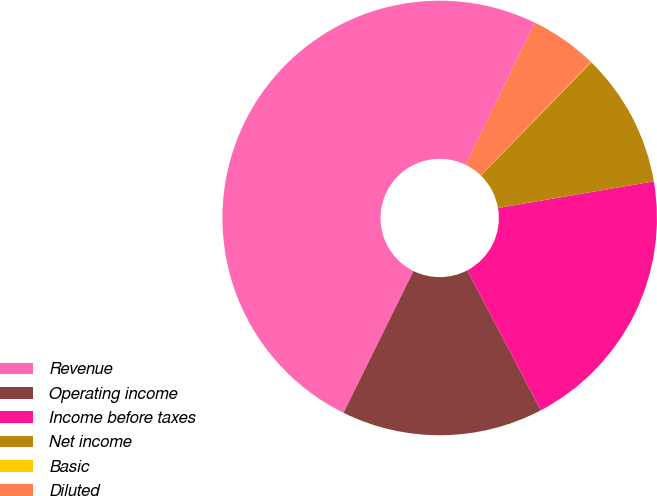Convert chart to OTSL. <chart><loc_0><loc_0><loc_500><loc_500><pie_chart><fcel>Revenue<fcel>Operating income<fcel>Income before taxes<fcel>Net income<fcel>Basic<fcel>Diluted<nl><fcel>49.91%<fcel>15.0%<fcel>19.99%<fcel>10.02%<fcel>0.04%<fcel>5.03%<nl></chart> 